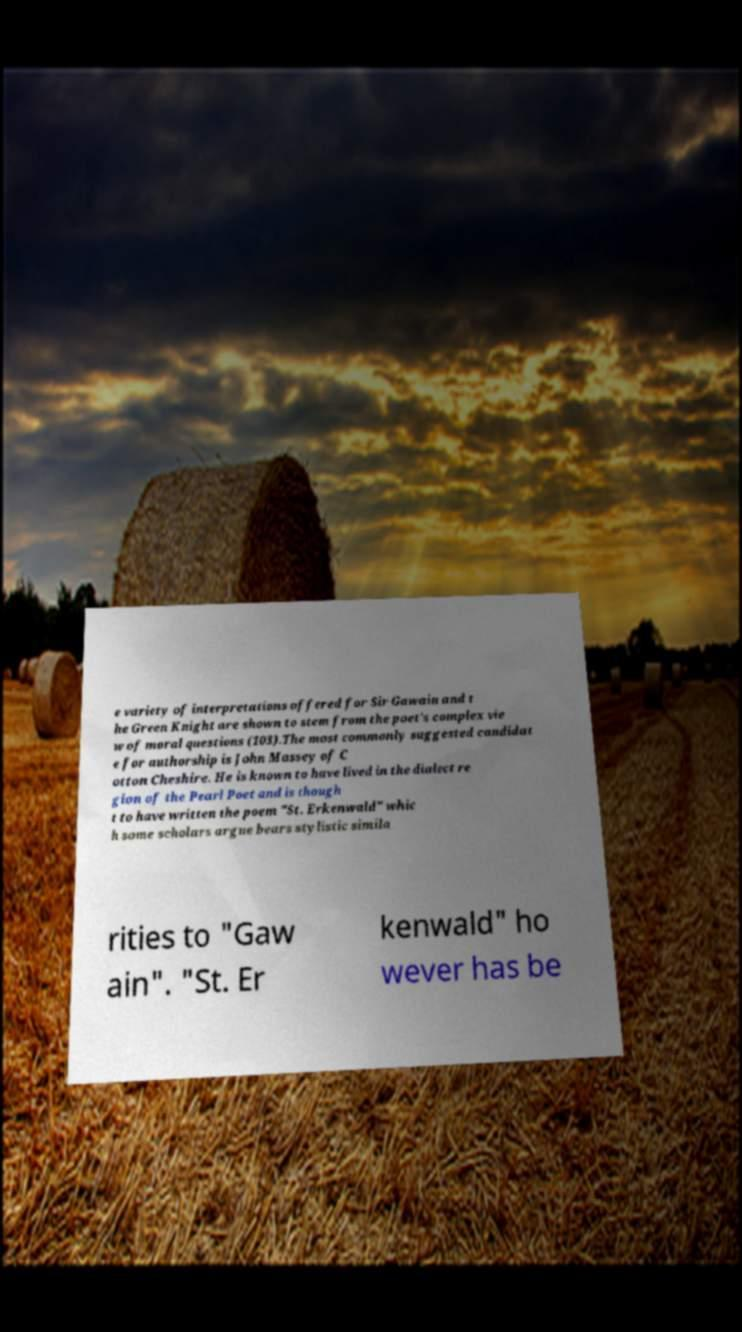There's text embedded in this image that I need extracted. Can you transcribe it verbatim? e variety of interpretations offered for Sir Gawain and t he Green Knight are shown to stem from the poet’s complex vie w of moral questions (103).The most commonly suggested candidat e for authorship is John Massey of C otton Cheshire. He is known to have lived in the dialect re gion of the Pearl Poet and is though t to have written the poem "St. Erkenwald" whic h some scholars argue bears stylistic simila rities to "Gaw ain". "St. Er kenwald" ho wever has be 